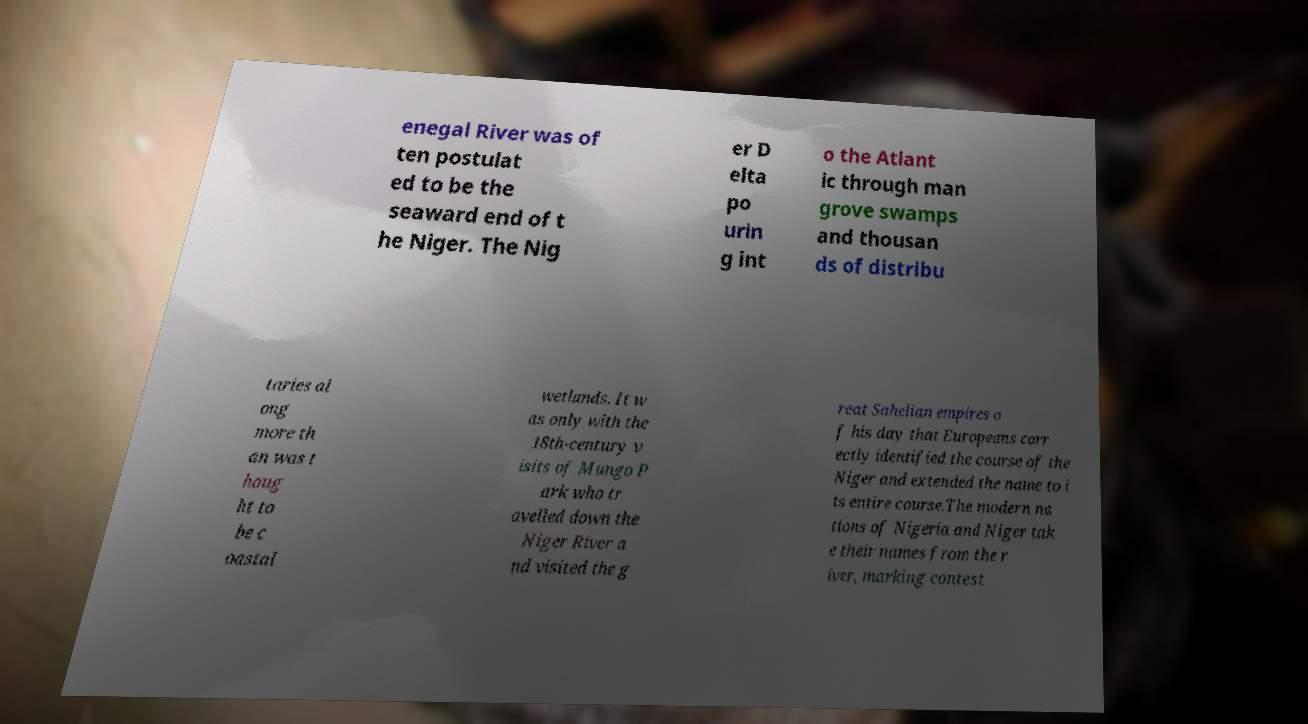Please identify and transcribe the text found in this image. enegal River was of ten postulat ed to be the seaward end of t he Niger. The Nig er D elta po urin g int o the Atlant ic through man grove swamps and thousan ds of distribu taries al ong more th an was t houg ht to be c oastal wetlands. It w as only with the 18th-century v isits of Mungo P ark who tr avelled down the Niger River a nd visited the g reat Sahelian empires o f his day that Europeans corr ectly identified the course of the Niger and extended the name to i ts entire course.The modern na tions of Nigeria and Niger tak e their names from the r iver, marking contest 